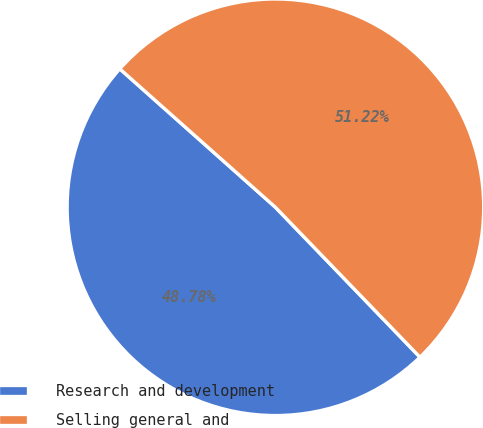<chart> <loc_0><loc_0><loc_500><loc_500><pie_chart><fcel>Research and development<fcel>Selling general and<nl><fcel>48.78%<fcel>51.22%<nl></chart> 